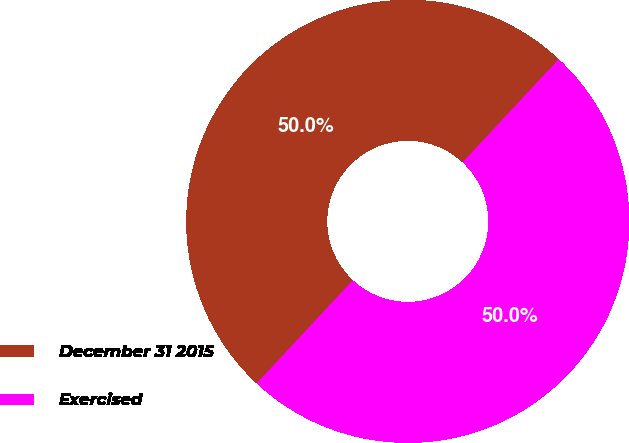Convert chart to OTSL. <chart><loc_0><loc_0><loc_500><loc_500><pie_chart><fcel>December 31 2015<fcel>Exercised<nl><fcel>49.99%<fcel>50.01%<nl></chart> 